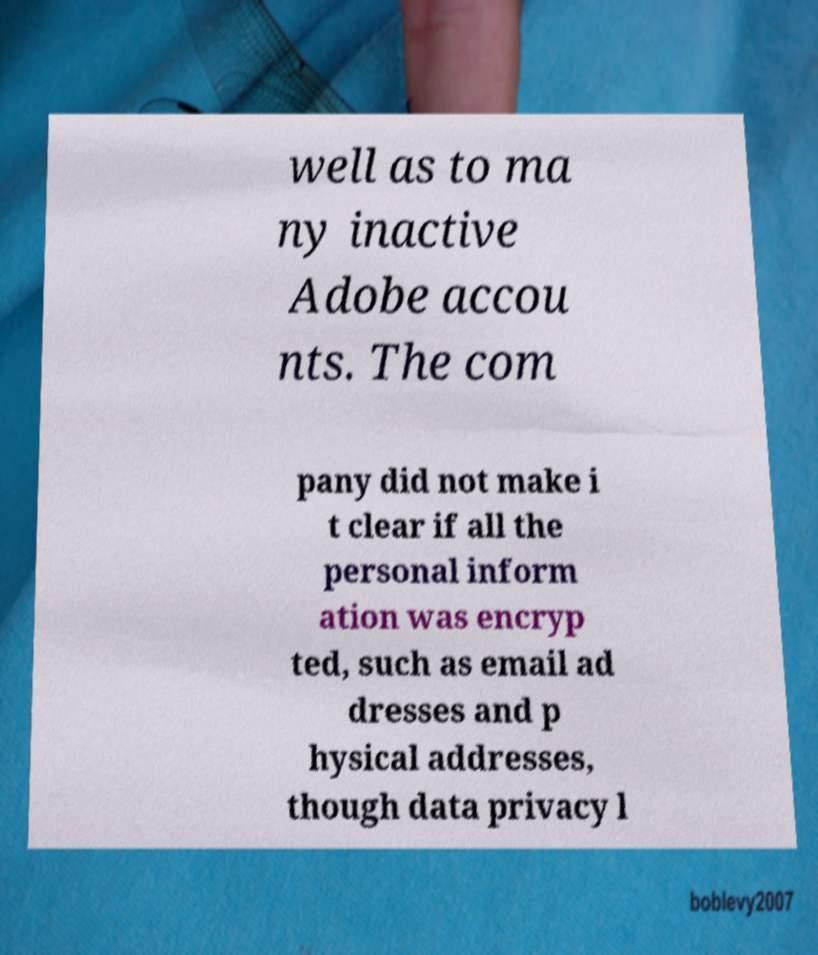What messages or text are displayed in this image? I need them in a readable, typed format. well as to ma ny inactive Adobe accou nts. The com pany did not make i t clear if all the personal inform ation was encryp ted, such as email ad dresses and p hysical addresses, though data privacy l 